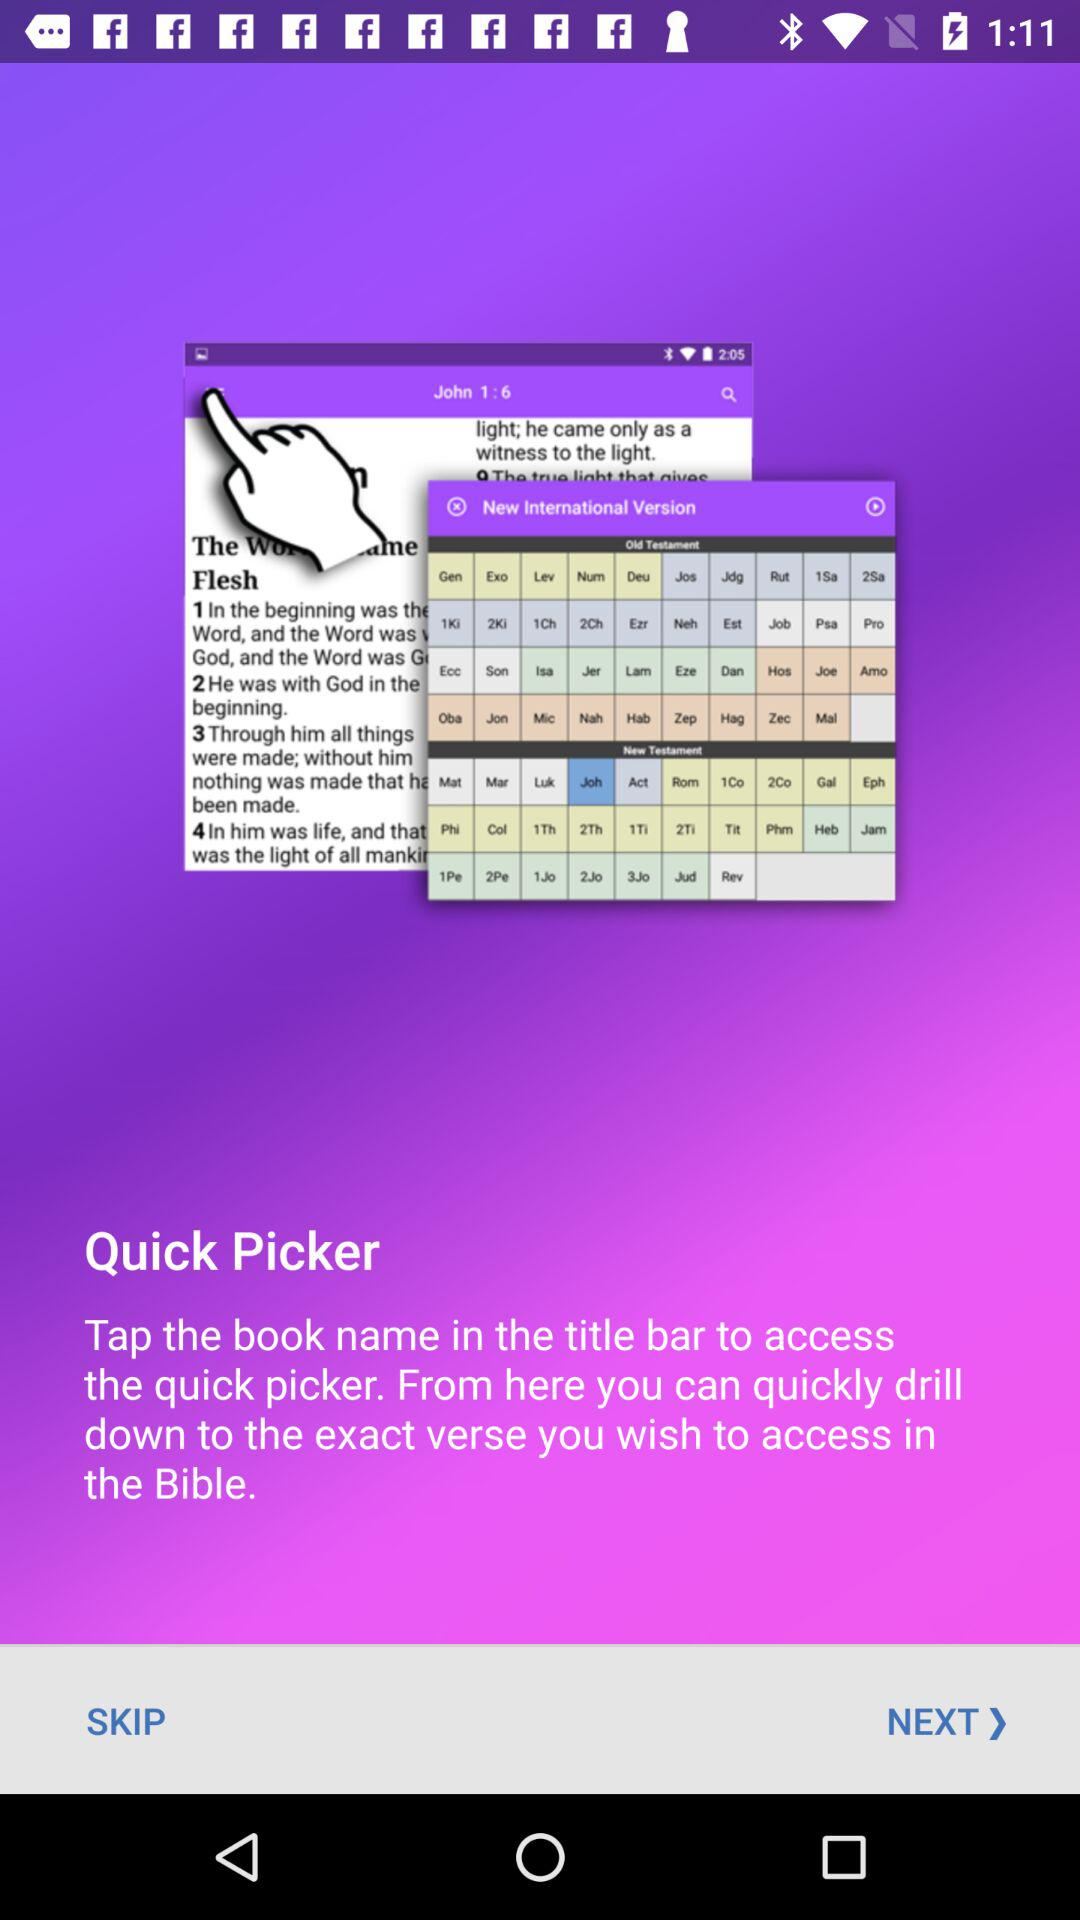What is quick picker?
When the provided information is insufficient, respond with <no answer>. <no answer> 